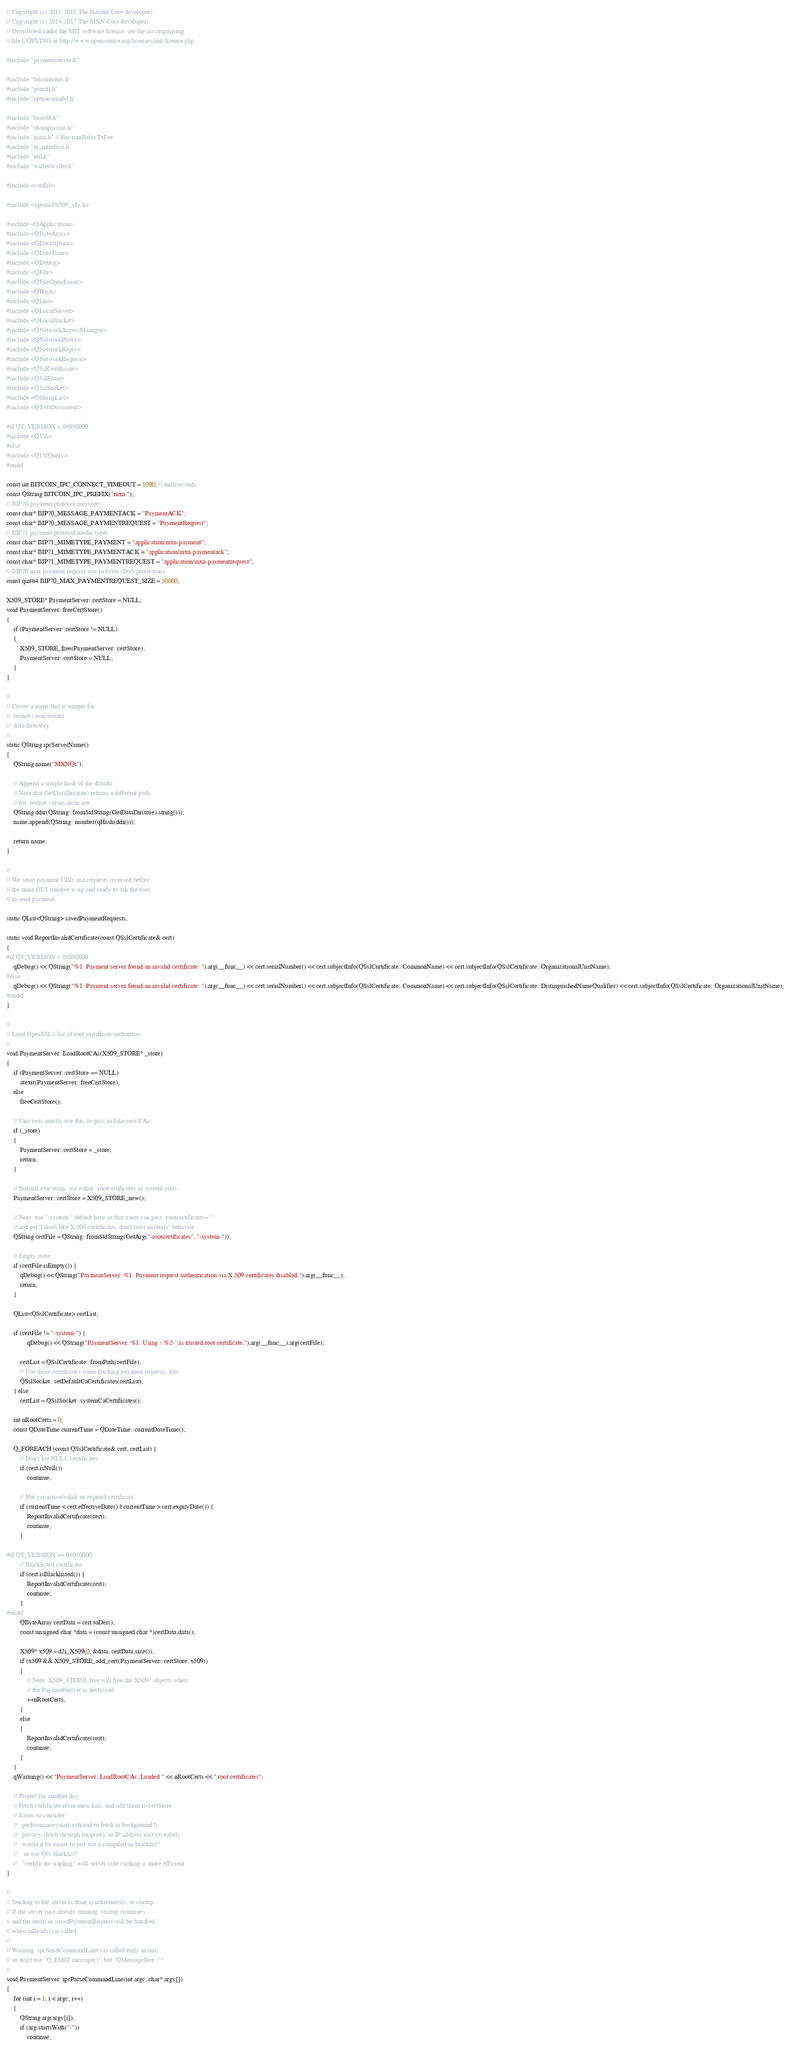Convert code to text. <code><loc_0><loc_0><loc_500><loc_500><_C++_>// Copyright (c) 2011-2015 The Bitcoin Core developers
// Copyright (c) 2014-2017 The MXN Core developers
// Distributed under the MIT software license, see the accompanying
// file COPYING or http://www.opensource.org/licenses/mit-license.php.

#include "paymentserver.h"

#include "bitcoinunits.h"
#include "guiutil.h"
#include "optionsmodel.h"

#include "base58.h"
#include "chainparams.h"
#include "main.h" // For minRelayTxFee
#include "ui_interface.h"
#include "util.h"
#include "wallet/wallet.h"

#include <cstdlib>

#include <openssl/x509_vfy.h>

#include <QApplication>
#include <QByteArray>
#include <QDataStream>
#include <QDateTime>
#include <QDebug>
#include <QFile>
#include <QFileOpenEvent>
#include <QHash>
#include <QList>
#include <QLocalServer>
#include <QLocalSocket>
#include <QNetworkAccessManager>
#include <QNetworkProxy>
#include <QNetworkReply>
#include <QNetworkRequest>
#include <QSslCertificate>
#include <QSslError>
#include <QSslSocket>
#include <QStringList>
#include <QTextDocument>

#if QT_VERSION < 0x050000
#include <QUrl>
#else
#include <QUrlQuery>
#endif

const int BITCOIN_IPC_CONNECT_TIMEOUT = 1000; // milliseconds
const QString BITCOIN_IPC_PREFIX("mxn:");
// BIP70 payment protocol messages
const char* BIP70_MESSAGE_PAYMENTACK = "PaymentACK";
const char* BIP70_MESSAGE_PAYMENTREQUEST = "PaymentRequest";
// BIP71 payment protocol media types
const char* BIP71_MIMETYPE_PAYMENT = "application/mxn-payment";
const char* BIP71_MIMETYPE_PAYMENTACK = "application/mxn-paymentack";
const char* BIP71_MIMETYPE_PAYMENTREQUEST = "application/mxn-paymentrequest";
// BIP70 max payment request size in bytes (DoS protection)
const qint64 BIP70_MAX_PAYMENTREQUEST_SIZE = 50000;

X509_STORE* PaymentServer::certStore = NULL;
void PaymentServer::freeCertStore()
{
    if (PaymentServer::certStore != NULL)
    {
        X509_STORE_free(PaymentServer::certStore);
        PaymentServer::certStore = NULL;
    }
}

//
// Create a name that is unique for:
//  testnet / non-testnet
//  data directory
//
static QString ipcServerName()
{
    QString name("MXNQt");

    // Append a simple hash of the datadir
    // Note that GetDataDir(true) returns a different path
    // for -testnet versus main net
    QString ddir(QString::fromStdString(GetDataDir(true).string()));
    name.append(QString::number(qHash(ddir)));

    return name;
}

//
// We store payment URIs and requests received before
// the main GUI window is up and ready to ask the user
// to send payment.

static QList<QString> savedPaymentRequests;

static void ReportInvalidCertificate(const QSslCertificate& cert)
{
#if QT_VERSION < 0x050000
    qDebug() << QString("%1: Payment server found an invalid certificate: ").arg(__func__) << cert.serialNumber() << cert.subjectInfo(QSslCertificate::CommonName) << cert.subjectInfo(QSslCertificate::OrganizationalUnitName);
#else
    qDebug() << QString("%1: Payment server found an invalid certificate: ").arg(__func__) << cert.serialNumber() << cert.subjectInfo(QSslCertificate::CommonName) << cert.subjectInfo(QSslCertificate::DistinguishedNameQualifier) << cert.subjectInfo(QSslCertificate::OrganizationalUnitName);
#endif
}

//
// Load OpenSSL's list of root certificate authorities
//
void PaymentServer::LoadRootCAs(X509_STORE* _store)
{
    if (PaymentServer::certStore == NULL)
        atexit(PaymentServer::freeCertStore);
    else
        freeCertStore();

    // Unit tests mostly use this, to pass in fake root CAs:
    if (_store)
    {
        PaymentServer::certStore = _store;
        return;
    }

    // Normal execution, use either -rootcertificates or system certs:
    PaymentServer::certStore = X509_STORE_new();

    // Note: use "-system-" default here so that users can pass -rootcertificates=""
    // and get 'I don't like X.509 certificates, don't trust anybody' behavior:
    QString certFile = QString::fromStdString(GetArg("-rootcertificates", "-system-"));

    // Empty store
    if (certFile.isEmpty()) {
        qDebug() << QString("PaymentServer::%1: Payment request authentication via X.509 certificates disabled.").arg(__func__);
        return;
    }

    QList<QSslCertificate> certList;

    if (certFile != "-system-") {
            qDebug() << QString("PaymentServer::%1: Using \"%2\" as trusted root certificate.").arg(__func__).arg(certFile);

        certList = QSslCertificate::fromPath(certFile);
        // Use those certificates when fetching payment requests, too:
        QSslSocket::setDefaultCaCertificates(certList);
    } else
        certList = QSslSocket::systemCaCertificates();

    int nRootCerts = 0;
    const QDateTime currentTime = QDateTime::currentDateTime();

    Q_FOREACH (const QSslCertificate& cert, certList) {
        // Don't log NULL certificates
        if (cert.isNull())
            continue;

        // Not yet active/valid, or expired certificate
        if (currentTime < cert.effectiveDate() || currentTime > cert.expiryDate()) {
            ReportInvalidCertificate(cert);
            continue;
        }

#if QT_VERSION >= 0x050000
        // Blacklisted certificate
        if (cert.isBlacklisted()) {
            ReportInvalidCertificate(cert);
            continue;
        }
#endif
        QByteArray certData = cert.toDer();
        const unsigned char *data = (const unsigned char *)certData.data();

        X509* x509 = d2i_X509(0, &data, certData.size());
        if (x509 && X509_STORE_add_cert(PaymentServer::certStore, x509))
        {
            // Note: X509_STORE_free will free the X509* objects when
            // the PaymentServer is destroyed
            ++nRootCerts;
        }
        else
        {
            ReportInvalidCertificate(cert);
            continue;
        }
    }
    qWarning() << "PaymentServer::LoadRootCAs: Loaded " << nRootCerts << " root certificates";

    // Project for another day:
    // Fetch certificate revocation lists, and add them to certStore.
    // Issues to consider:
    //   performance (start a thread to fetch in background?)
    //   privacy (fetch through tor/proxy so IP address isn't revealed)
    //   would it be easier to just use a compiled-in blacklist?
    //    or use Qt's blacklist?
    //   "certificate stapling" with server-side caching is more efficient
}

//
// Sending to the server is done synchronously, at startup.
// If the server isn't already running, startup continues,
// and the items in savedPaymentRequest will be handled
// when uiReady() is called.
//
// Warning: ipcSendCommandLine() is called early in init,
// so don't use "Q_EMIT message()", but "QMessageBox::"!
//
void PaymentServer::ipcParseCommandLine(int argc, char* argv[])
{
    for (int i = 1; i < argc; i++)
    {
        QString arg(argv[i]);
        if (arg.startsWith("-"))
            continue;
</code> 